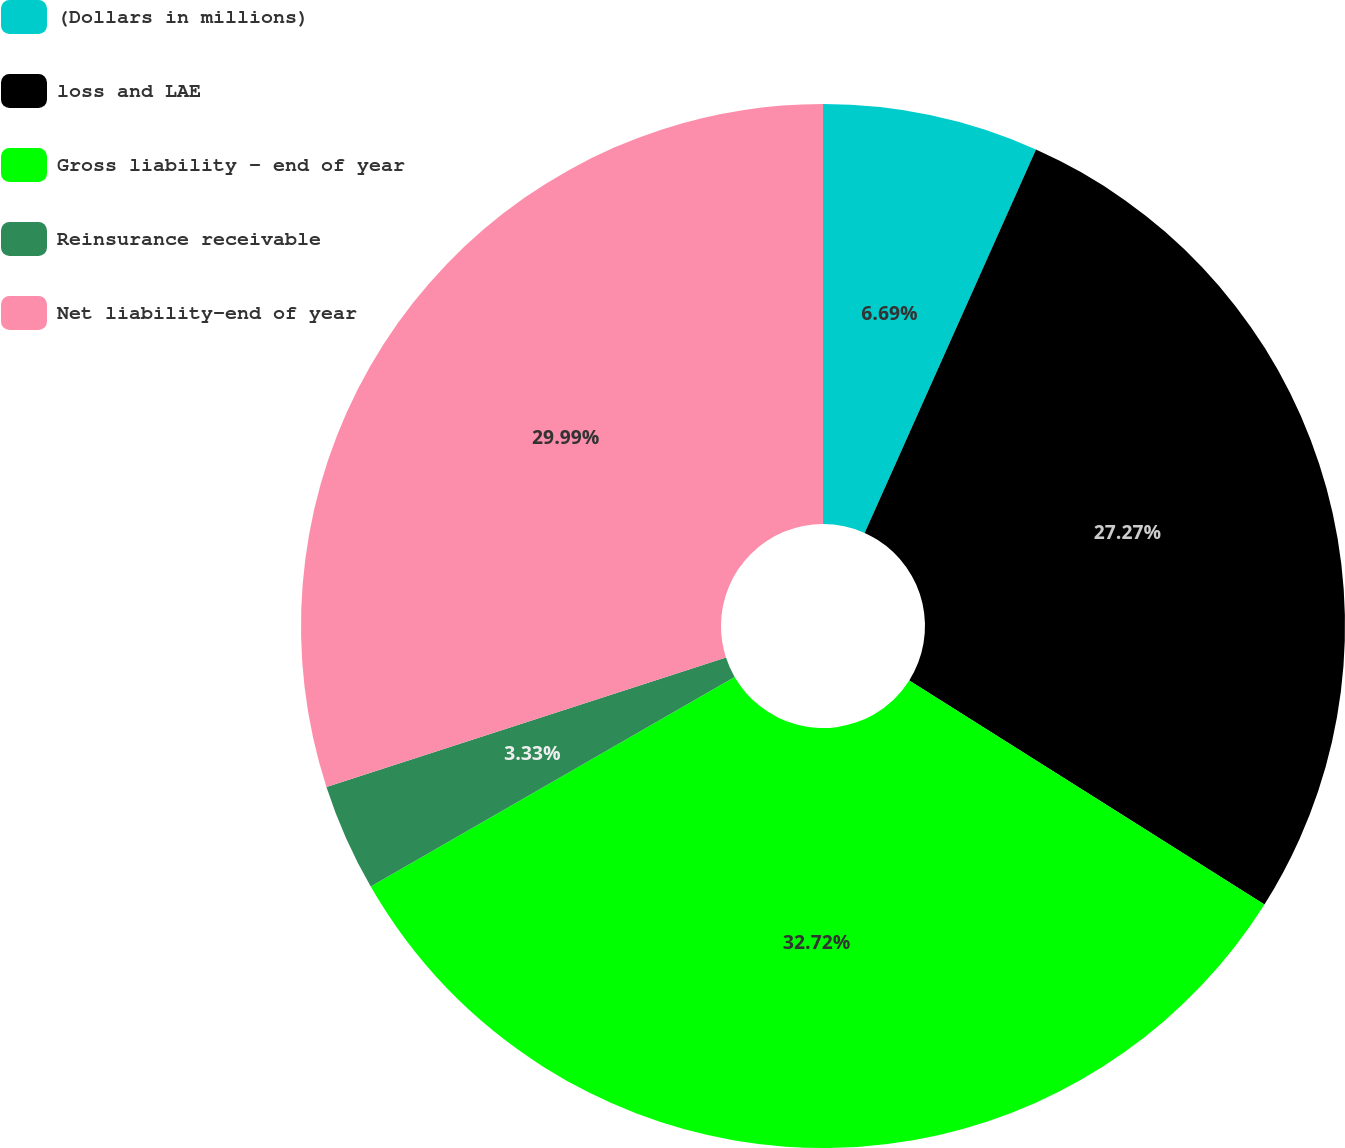Convert chart. <chart><loc_0><loc_0><loc_500><loc_500><pie_chart><fcel>(Dollars in millions)<fcel>loss and LAE<fcel>Gross liability - end of year<fcel>Reinsurance receivable<fcel>Net liability-end of year<nl><fcel>6.69%<fcel>27.27%<fcel>32.72%<fcel>3.33%<fcel>29.99%<nl></chart> 